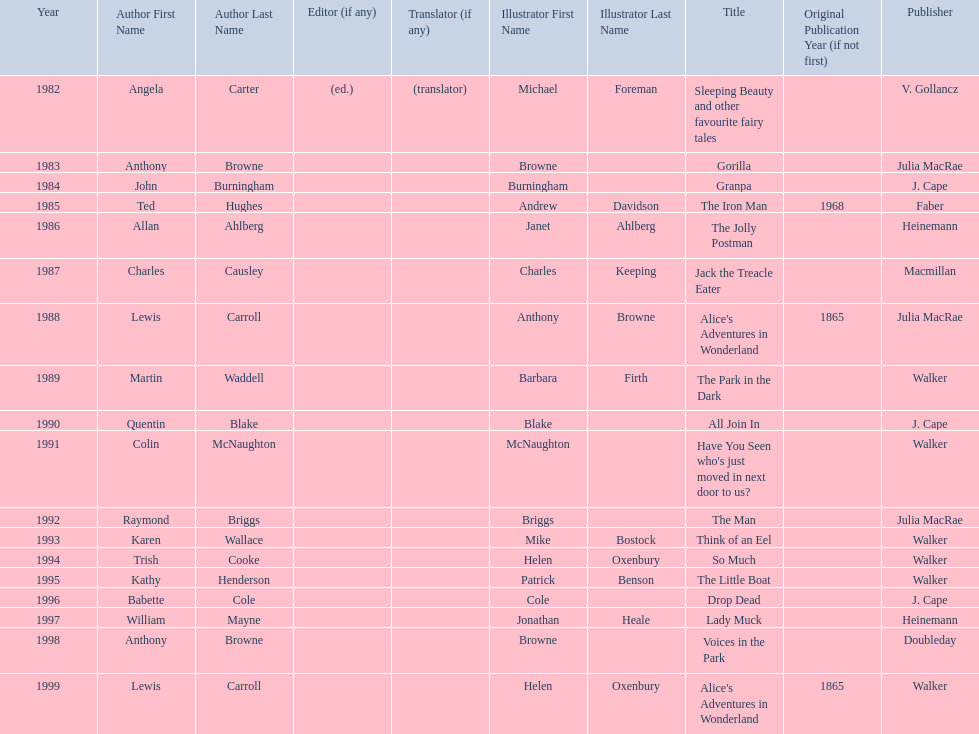Which title was after the year 1991 but before the year 1993? The Man. 